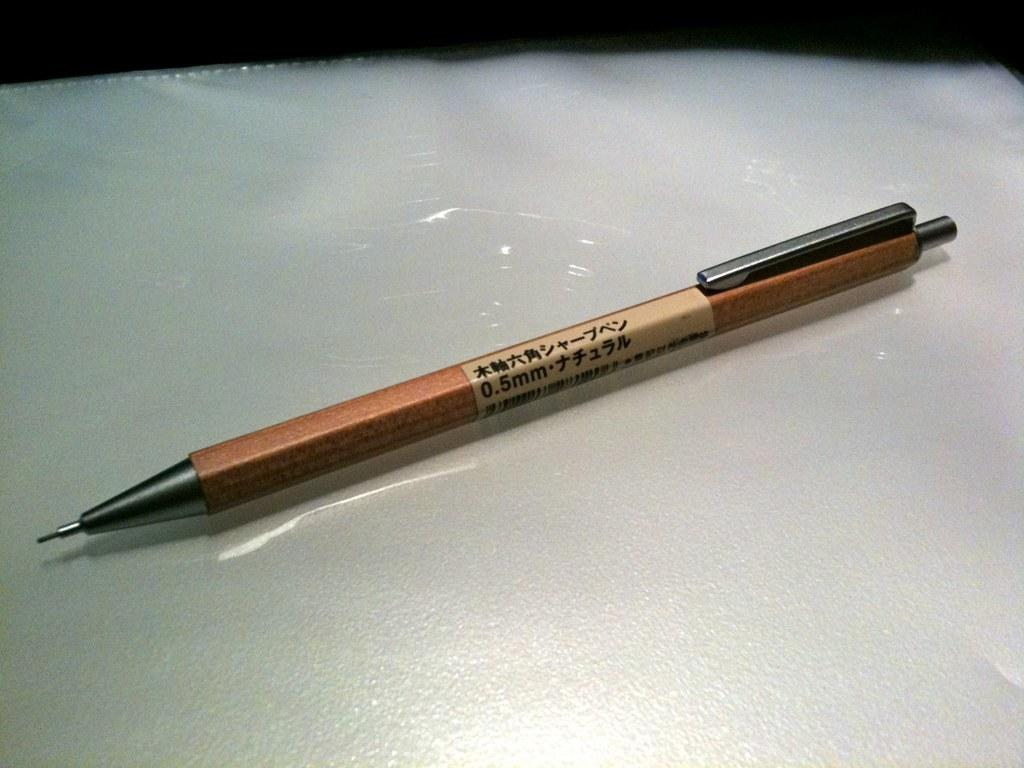What type of writing instrument is in the image? There is a brown pen and a brown pencil in the image. How are the pen and pencil positioned in the image? The pen and pencil are placed on a white surface. What color are the pen and pencil? The pen and pencil are both brown. How many laborers are visible in the image? There are no laborers present in the image; it only features a brown pen and a brown pencil on a white surface. What type of kite is being flown in the image? There is no kite present in the image; it only features a brown pen and a brown pencil on a white surface. 